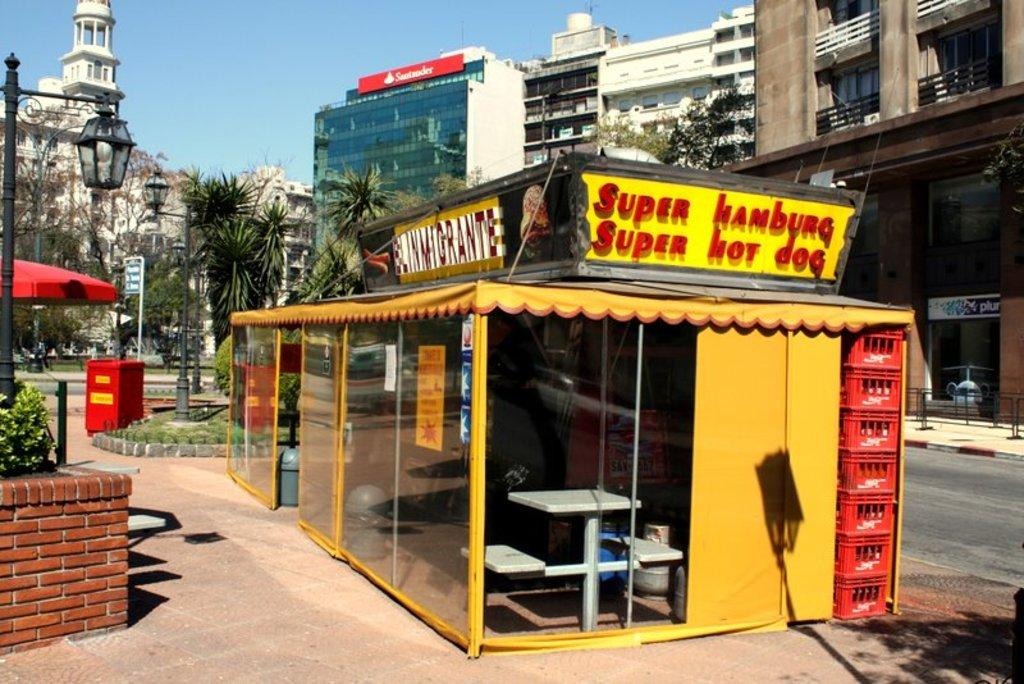What type of structures can be seen in the image? There are many buildings visible in the image. What other natural elements can be seen in the image? There are trees in the image. Is there any man-made infrastructure visible in the image? Yes, there is a road in the image. Can you describe any medical equipment present in the image? Snake stents are present in the image. Can you tell me how many people are swimming around the island in the image? There is no island or people swimming present in the image. What type of jewelry can be seen on the person in the image? There is no person or locket present in the image. 